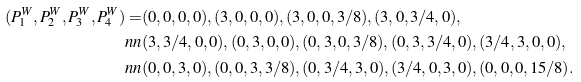<formula> <loc_0><loc_0><loc_500><loc_500>( P ^ { W } _ { 1 } , P ^ { W } _ { 2 } , P ^ { W } _ { 3 } , P ^ { W } _ { 4 } ) = & ( 0 , 0 , 0 , 0 ) , ( 3 , 0 , 0 , 0 ) , ( 3 , 0 , 0 , 3 / 8 ) , ( 3 , 0 , 3 / 4 , 0 ) , \\ \ n n & ( 3 , 3 / 4 , 0 , 0 ) , ( 0 , 3 , 0 , 0 ) , ( 0 , 3 , 0 , 3 / 8 ) , ( 0 , 3 , 3 / 4 , 0 ) , ( 3 / 4 , 3 , 0 , 0 ) , \\ \ n n & ( 0 , 0 , 3 , 0 ) , ( 0 , 0 , 3 , 3 / 8 ) , ( 0 , 3 / 4 , 3 , 0 ) , ( 3 / 4 , 0 , 3 , 0 ) , ( 0 , 0 , 0 , 1 5 / 8 ) .</formula> 